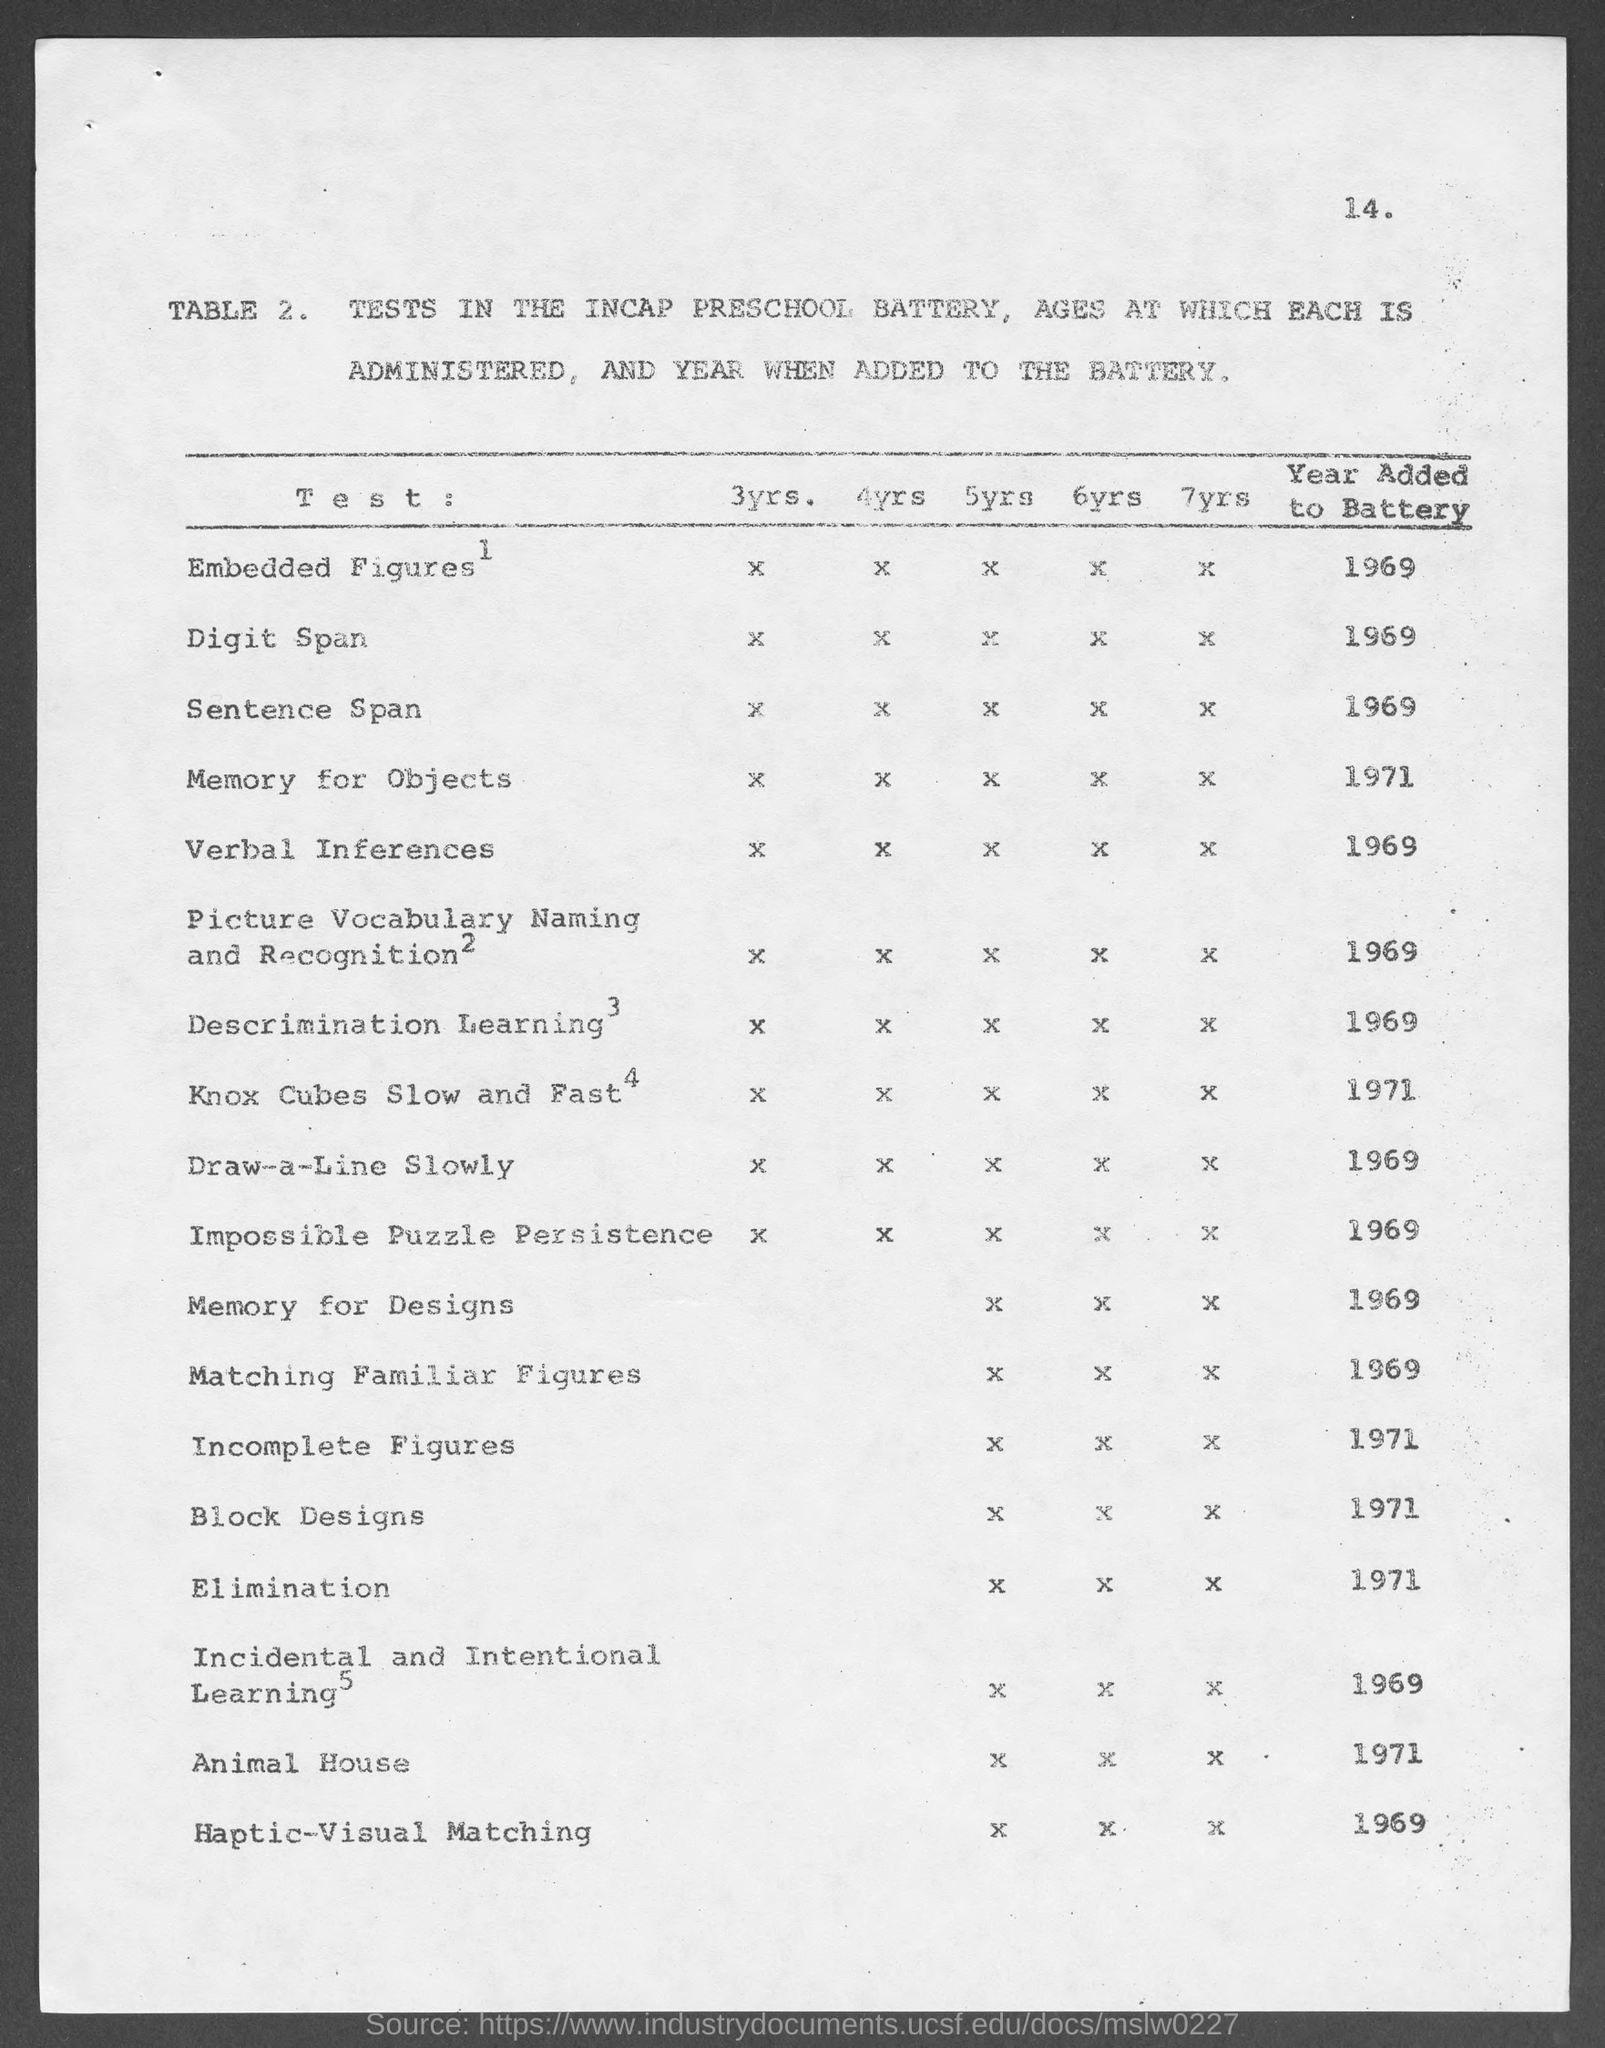Specify some key components in this picture. The year added to the battery for Animal House is 1971. The year added to the battery for memory objects is 1971. The year added to the battery in discrimination learning is 1969. The year added to the battery for Verbal Inferences is 1969. The year added to the battery for embedded figures is 1969. 